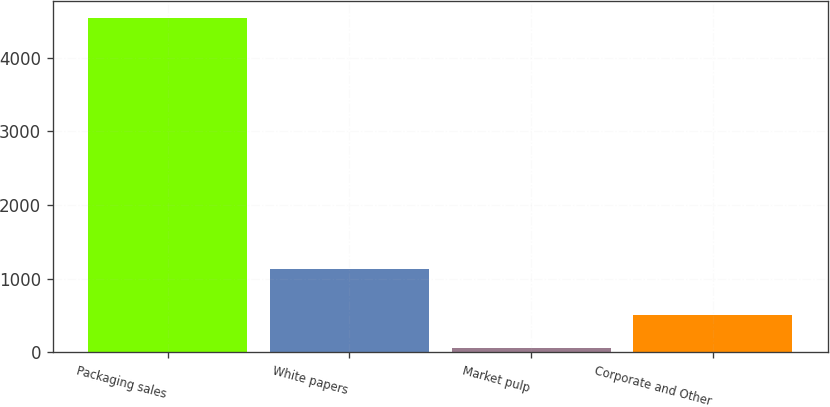Convert chart. <chart><loc_0><loc_0><loc_500><loc_500><bar_chart><fcel>Packaging sales<fcel>White papers<fcel>Market pulp<fcel>Corporate and Other<nl><fcel>4540.3<fcel>1138.5<fcel>62.9<fcel>510.64<nl></chart> 